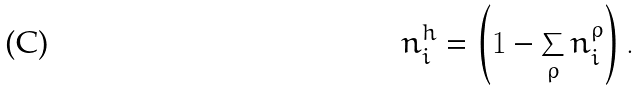<formula> <loc_0><loc_0><loc_500><loc_500>n _ { i } ^ { h } = \left ( 1 - \sum _ { \rho } n _ { i } ^ { \rho } \right ) .</formula> 